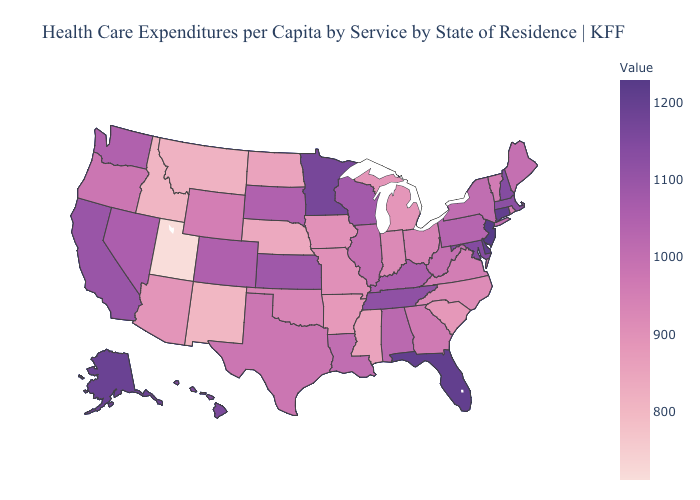Among the states that border Arkansas , which have the highest value?
Short answer required. Tennessee. Does Texas have the lowest value in the USA?
Be succinct. No. Among the states that border Vermont , does New Hampshire have the highest value?
Quick response, please. Yes. Does New York have the highest value in the Northeast?
Give a very brief answer. No. Among the states that border Delaware , does New Jersey have the highest value?
Short answer required. Yes. Which states have the lowest value in the MidWest?
Be succinct. Nebraska. 